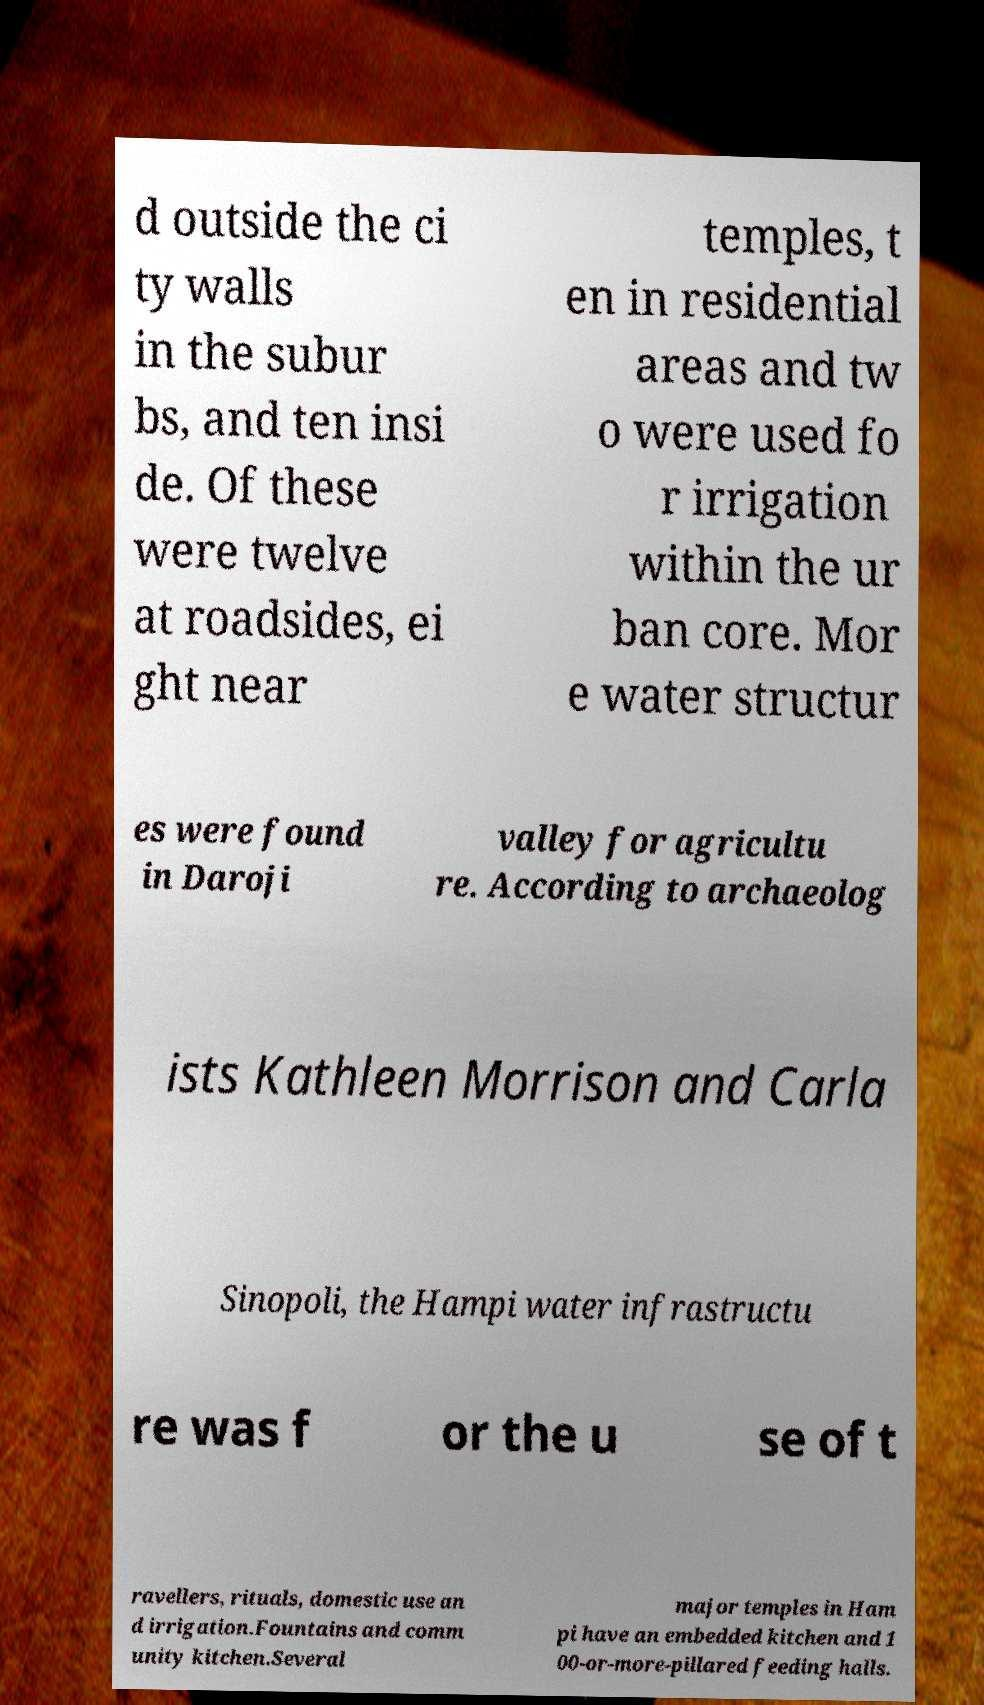Can you read and provide the text displayed in the image?This photo seems to have some interesting text. Can you extract and type it out for me? d outside the ci ty walls in the subur bs, and ten insi de. Of these were twelve at roadsides, ei ght near temples, t en in residential areas and tw o were used fo r irrigation within the ur ban core. Mor e water structur es were found in Daroji valley for agricultu re. According to archaeolog ists Kathleen Morrison and Carla Sinopoli, the Hampi water infrastructu re was f or the u se of t ravellers, rituals, domestic use an d irrigation.Fountains and comm unity kitchen.Several major temples in Ham pi have an embedded kitchen and 1 00-or-more-pillared feeding halls. 